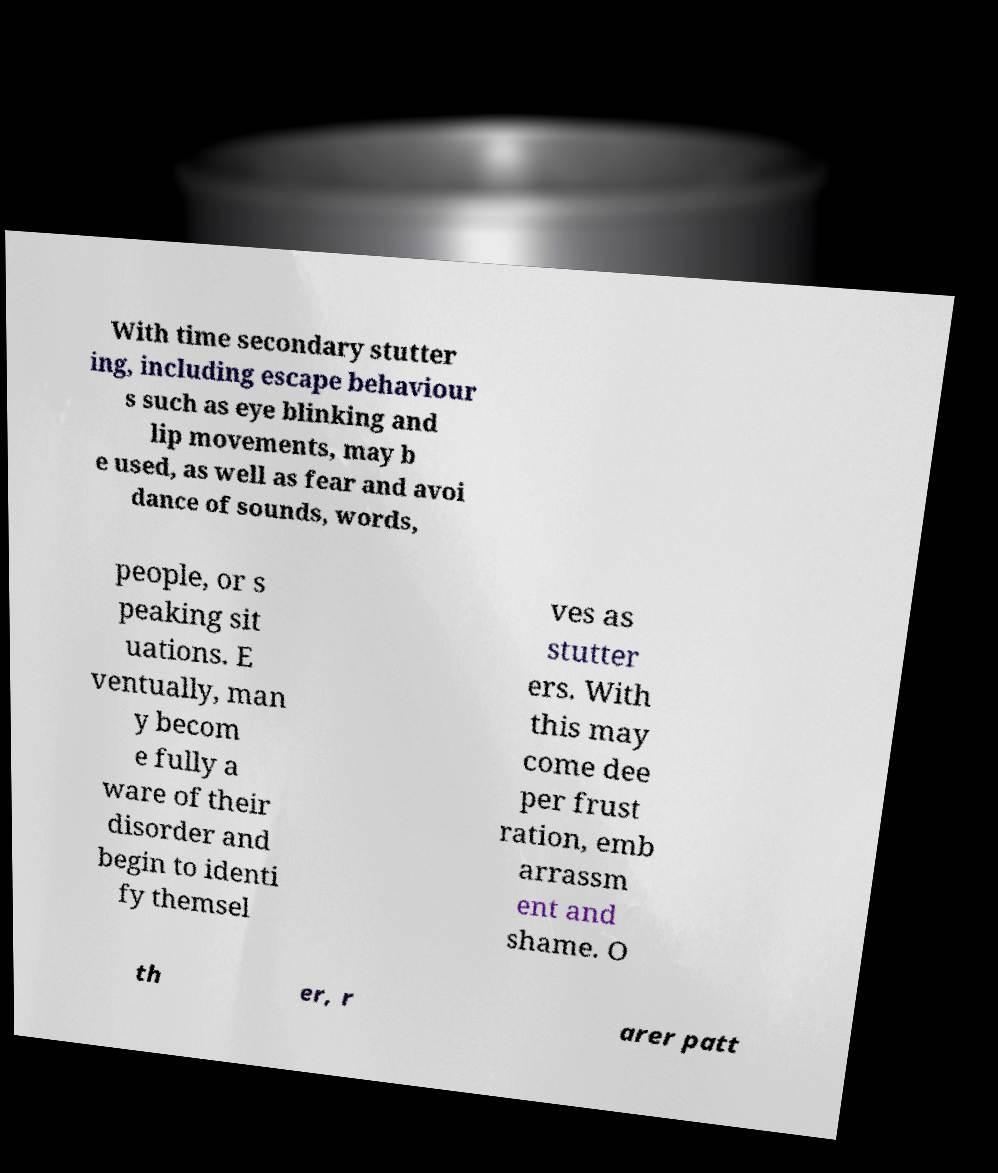Could you extract and type out the text from this image? With time secondary stutter ing, including escape behaviour s such as eye blinking and lip movements, may b e used, as well as fear and avoi dance of sounds, words, people, or s peaking sit uations. E ventually, man y becom e fully a ware of their disorder and begin to identi fy themsel ves as stutter ers. With this may come dee per frust ration, emb arrassm ent and shame. O th er, r arer patt 